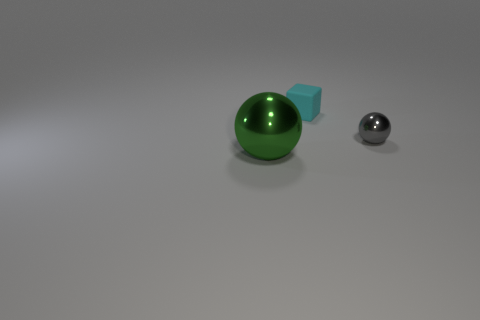Add 1 brown matte cylinders. How many objects exist? 4 Subtract all balls. How many objects are left? 1 Add 2 big green rubber blocks. How many big green rubber blocks exist? 2 Subtract 1 cyan cubes. How many objects are left? 2 Subtract all green cubes. Subtract all cyan balls. How many cubes are left? 1 Subtract all brown cylinders. How many gray spheres are left? 1 Subtract all small blue metal cubes. Subtract all matte things. How many objects are left? 2 Add 3 gray balls. How many gray balls are left? 4 